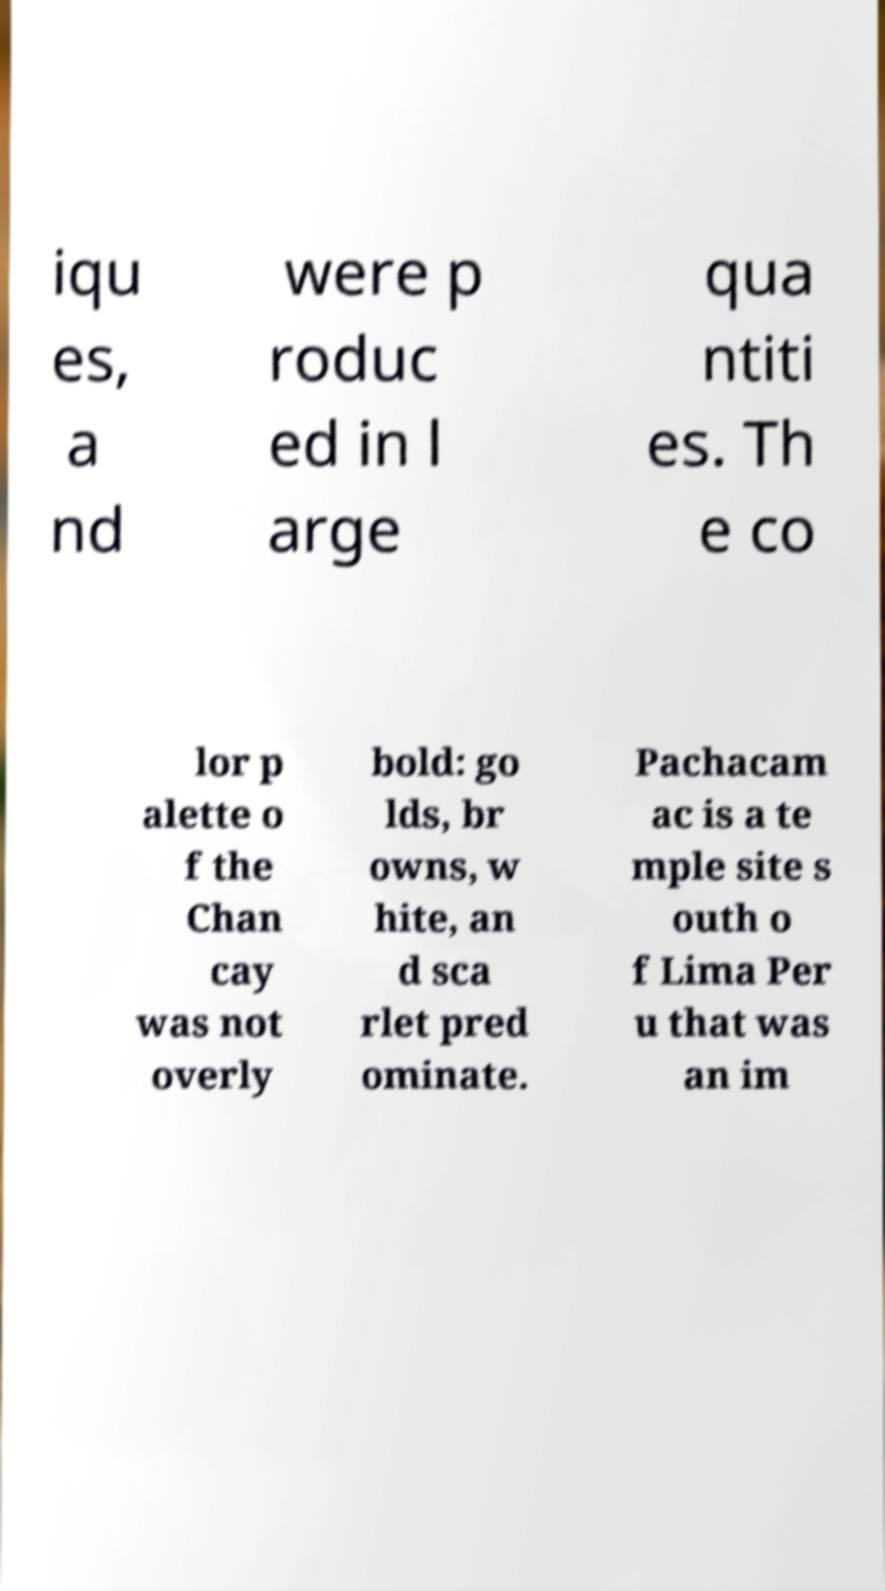Please identify and transcribe the text found in this image. iqu es, a nd were p roduc ed in l arge qua ntiti es. Th e co lor p alette o f the Chan cay was not overly bold: go lds, br owns, w hite, an d sca rlet pred ominate. Pachacam ac is a te mple site s outh o f Lima Per u that was an im 